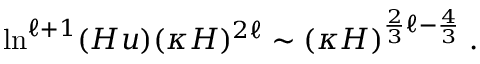<formula> <loc_0><loc_0><loc_500><loc_500>\ln ^ { \ell + 1 } ( H u ) ( \kappa H ) ^ { 2 \ell } \sim ( \kappa H ) ^ { \frac { 2 } { 3 } \ell - \frac { 4 } { 3 } } \, .</formula> 